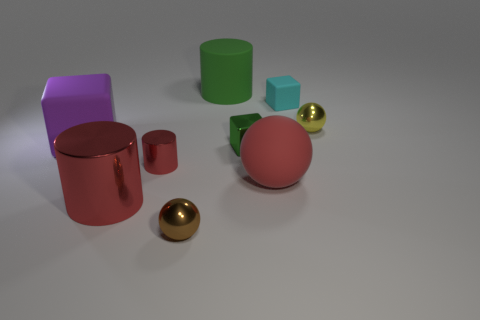Subtract 1 cylinders. How many cylinders are left? 2 Subtract all red shiny cylinders. How many cylinders are left? 1 Subtract all cylinders. How many objects are left? 6 Add 5 rubber objects. How many rubber objects are left? 9 Add 6 tiny red metallic balls. How many tiny red metallic balls exist? 6 Subtract 0 green balls. How many objects are left? 9 Subtract all large balls. Subtract all tiny cyan matte objects. How many objects are left? 7 